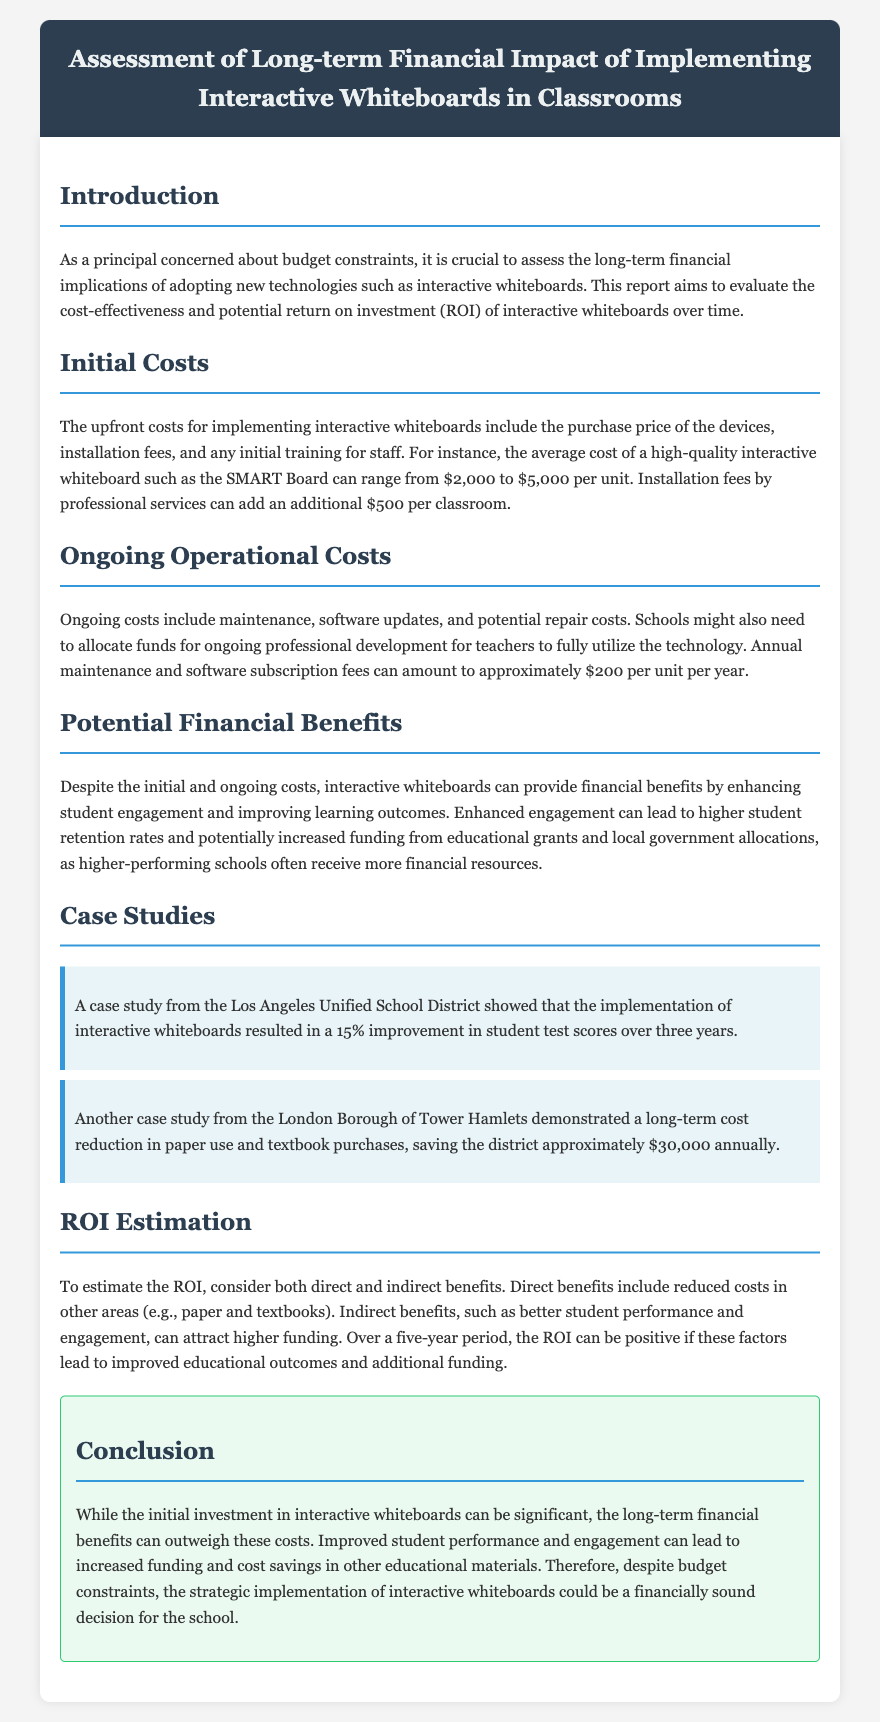what is the average cost of an interactive whiteboard? The average cost of a high-quality interactive whiteboard such as the SMART Board can range from $2,000 to $5,000 per unit.
Answer: $2,000 to $5,000 what are the ongoing operational costs per unit per year? Ongoing costs include maintenance and software subscription fees that can amount to approximately $200 per unit per year.
Answer: $200 what was the percentage improvement in student test scores in Los Angeles? A case study from the Los Angeles Unified School District showed a 15% improvement in student test scores over three years.
Answer: 15% how much money did the London Borough of Tower Hamlets save annually? The London Borough of Tower Hamlets demonstrated a long-term cost reduction in paper use and textbook purchases, saving the district approximately $30,000 annually.
Answer: $30,000 what is the report's conclusion regarding interactive whiteboards and budget constraints? The conclusion states that despite budget constraints, the strategic implementation of interactive whiteboards could be a financially sound decision for the school.
Answer: financially sound decision what is the main focus of this report? The report focuses on evaluating the cost-effectiveness and potential return on investment (ROI) of interactive whiteboards over time.
Answer: cost-effectiveness and potential return on investment what type of costs are included in initial costs? Initial costs include the purchase price of the devices, installation fees, and initial training for staff.
Answer: purchase price, installation fees, initial training which section discusses the financial benefits of interactive whiteboards? The section that discusses financial benefits is titled "Potential Financial Benefits".
Answer: Potential Financial Benefits 